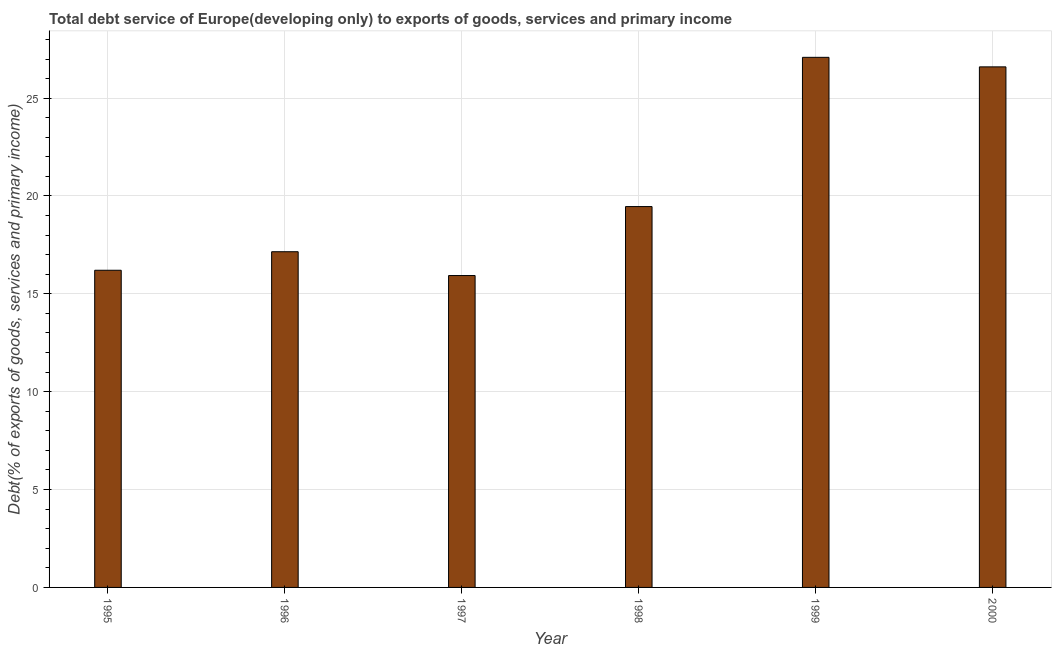Does the graph contain grids?
Keep it short and to the point. Yes. What is the title of the graph?
Your answer should be compact. Total debt service of Europe(developing only) to exports of goods, services and primary income. What is the label or title of the X-axis?
Ensure brevity in your answer.  Year. What is the label or title of the Y-axis?
Give a very brief answer. Debt(% of exports of goods, services and primary income). What is the total debt service in 1998?
Offer a very short reply. 19.46. Across all years, what is the maximum total debt service?
Keep it short and to the point. 27.09. Across all years, what is the minimum total debt service?
Offer a terse response. 15.94. What is the sum of the total debt service?
Offer a very short reply. 122.44. What is the difference between the total debt service in 1995 and 1998?
Make the answer very short. -3.25. What is the average total debt service per year?
Your response must be concise. 20.41. What is the median total debt service?
Your answer should be compact. 18.31. What is the ratio of the total debt service in 1997 to that in 1999?
Your response must be concise. 0.59. Is the difference between the total debt service in 1995 and 1999 greater than the difference between any two years?
Keep it short and to the point. No. What is the difference between the highest and the second highest total debt service?
Offer a terse response. 0.49. Is the sum of the total debt service in 1995 and 1996 greater than the maximum total debt service across all years?
Ensure brevity in your answer.  Yes. What is the difference between the highest and the lowest total debt service?
Provide a succinct answer. 11.15. In how many years, is the total debt service greater than the average total debt service taken over all years?
Your answer should be very brief. 2. Are all the bars in the graph horizontal?
Give a very brief answer. No. How many years are there in the graph?
Provide a succinct answer. 6. Are the values on the major ticks of Y-axis written in scientific E-notation?
Provide a short and direct response. No. What is the Debt(% of exports of goods, services and primary income) of 1995?
Offer a terse response. 16.21. What is the Debt(% of exports of goods, services and primary income) in 1996?
Keep it short and to the point. 17.15. What is the Debt(% of exports of goods, services and primary income) of 1997?
Ensure brevity in your answer.  15.94. What is the Debt(% of exports of goods, services and primary income) in 1998?
Provide a succinct answer. 19.46. What is the Debt(% of exports of goods, services and primary income) of 1999?
Make the answer very short. 27.09. What is the Debt(% of exports of goods, services and primary income) in 2000?
Provide a short and direct response. 26.6. What is the difference between the Debt(% of exports of goods, services and primary income) in 1995 and 1996?
Your answer should be compact. -0.95. What is the difference between the Debt(% of exports of goods, services and primary income) in 1995 and 1997?
Ensure brevity in your answer.  0.27. What is the difference between the Debt(% of exports of goods, services and primary income) in 1995 and 1998?
Provide a succinct answer. -3.25. What is the difference between the Debt(% of exports of goods, services and primary income) in 1995 and 1999?
Make the answer very short. -10.88. What is the difference between the Debt(% of exports of goods, services and primary income) in 1995 and 2000?
Your answer should be very brief. -10.39. What is the difference between the Debt(% of exports of goods, services and primary income) in 1996 and 1997?
Provide a succinct answer. 1.22. What is the difference between the Debt(% of exports of goods, services and primary income) in 1996 and 1998?
Your response must be concise. -2.31. What is the difference between the Debt(% of exports of goods, services and primary income) in 1996 and 1999?
Offer a very short reply. -9.93. What is the difference between the Debt(% of exports of goods, services and primary income) in 1996 and 2000?
Your response must be concise. -9.45. What is the difference between the Debt(% of exports of goods, services and primary income) in 1997 and 1998?
Offer a terse response. -3.52. What is the difference between the Debt(% of exports of goods, services and primary income) in 1997 and 1999?
Keep it short and to the point. -11.15. What is the difference between the Debt(% of exports of goods, services and primary income) in 1997 and 2000?
Your answer should be very brief. -10.66. What is the difference between the Debt(% of exports of goods, services and primary income) in 1998 and 1999?
Your response must be concise. -7.63. What is the difference between the Debt(% of exports of goods, services and primary income) in 1998 and 2000?
Your response must be concise. -7.14. What is the difference between the Debt(% of exports of goods, services and primary income) in 1999 and 2000?
Make the answer very short. 0.49. What is the ratio of the Debt(% of exports of goods, services and primary income) in 1995 to that in 1996?
Make the answer very short. 0.94. What is the ratio of the Debt(% of exports of goods, services and primary income) in 1995 to that in 1998?
Provide a succinct answer. 0.83. What is the ratio of the Debt(% of exports of goods, services and primary income) in 1995 to that in 1999?
Offer a very short reply. 0.6. What is the ratio of the Debt(% of exports of goods, services and primary income) in 1995 to that in 2000?
Make the answer very short. 0.61. What is the ratio of the Debt(% of exports of goods, services and primary income) in 1996 to that in 1997?
Your answer should be compact. 1.08. What is the ratio of the Debt(% of exports of goods, services and primary income) in 1996 to that in 1998?
Ensure brevity in your answer.  0.88. What is the ratio of the Debt(% of exports of goods, services and primary income) in 1996 to that in 1999?
Keep it short and to the point. 0.63. What is the ratio of the Debt(% of exports of goods, services and primary income) in 1996 to that in 2000?
Your response must be concise. 0.65. What is the ratio of the Debt(% of exports of goods, services and primary income) in 1997 to that in 1998?
Offer a terse response. 0.82. What is the ratio of the Debt(% of exports of goods, services and primary income) in 1997 to that in 1999?
Offer a terse response. 0.59. What is the ratio of the Debt(% of exports of goods, services and primary income) in 1997 to that in 2000?
Provide a succinct answer. 0.6. What is the ratio of the Debt(% of exports of goods, services and primary income) in 1998 to that in 1999?
Your answer should be very brief. 0.72. What is the ratio of the Debt(% of exports of goods, services and primary income) in 1998 to that in 2000?
Make the answer very short. 0.73. 